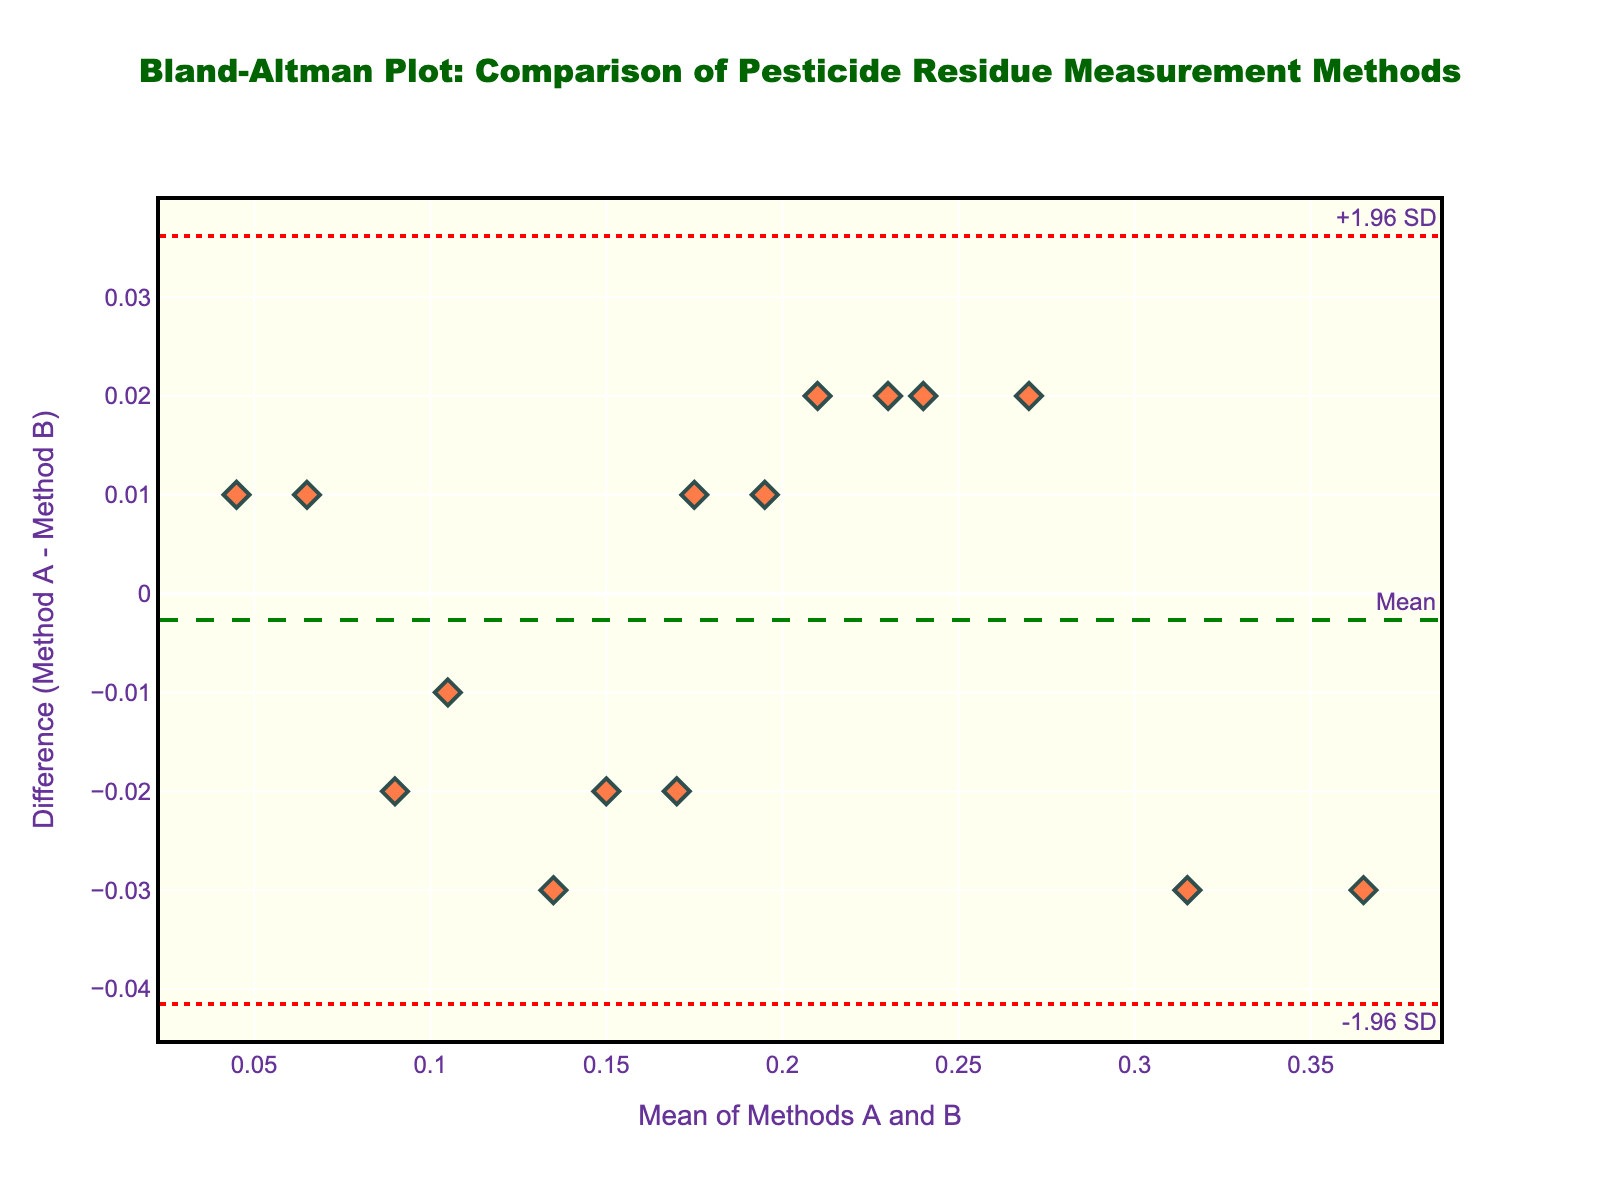What is the title of the figure? The title is usually positioned at the top of the figure. It provides a concise description of what the plot is about. In this case, the title is "Bland-Altman Plot: Comparison of Pesticide Residue Measurement Methods".
Answer: "Bland-Altman Plot: Comparison of Pesticide Residue Measurement Methods" What do the x-axis and y-axis represent in the figure? The x-axis typically represents the mean of the two methods (Method A and Method B) for each data point, and the y-axis shows the difference between Method A and Method B for those data points. The labels on the axes confirm this: "Mean of Methods A and B" for the x-axis and "Difference (Method A - Method B)" for the y-axis.
Answer: The x-axis is the Mean of Methods A and B, and the y-axis is the Difference (Method A - Method B) How many data points are displayed in the plot? To determine the number of data points, count the diamond markers on the scatter plot. Each marker represents a pair of measurements from Method A and Method B. By counting the markers, you can confirm the number of data points. In this case, there are 15 markers.
Answer: 15 What color are the data points in the plot? The color of the data points can be observed visually. In this plot, the markers are colored in a shade of red, described as "rgba(255, 69, 0, 0.7)".
Answer: Red Is there any trend visible in the differences between Methods A and B with respect to the mean of the methods? To identify a trend, look at whether the differences (y-axis values) systematically increase or decrease as the mean (x-axis values) increase. If the points are randomly scattered around the mean difference line with no clear pattern, it suggests no trend. Otherwise, a clear pattern or slope would indicate a trend. In this plot, the points are fairly evenly scattered around the mean difference line without a clear pattern, suggesting no trend.
Answer: No trend visible Which data point has the largest positive difference between Method A and Method B? The largest positive difference will be the data point that is highest above the zero reference line on the y-axis. In this plot, it's the point around x=0.33, y=0.03. By checking the data for verification, this point corresponds to a mean of 0.33 and a difference of 0.03, from the pair (0.30, 0.33).
Answer: The point at (Mean: 0.33, Difference: 0.03) Are there more measurements above or below the mean difference line? To determine this, visually count the number of data points positioned above and below the mean difference line (the dashed green line). Count each group and compare. More data points below the line indicate more frequent lower differences between the methods and vice versa. In this plot, there seem to be 7 points above and 8 points below.
Answer: More measurements below the mean difference line What does it mean if a point is outside the limits of agreement (LoA)? A point outside the LoA (dotted red lines) indicates that the difference between the two methods for that particular measurement pair is unusually large, suggesting potential issues or discrepancies with those measurements. It reflects significant disagreement between the methods for that specific instance. Examine the plot for any points outside these lines. If the plot has no points outside the LoA lines, it means all differences are within acceptable limits of agreement. Given this plot, all points are within the limits.
Answer: It indicates significant disagreement between the methods for that measurement What is the overall agreement between Method A and Method B based on the Bland-Altman plot? The overall agreement can be inferred by the distribution of points relative to the mean difference line and the limits of agreement. If most points are close to the mean difference line and within the LoA, it suggests good agreement. If points are scattered widely and many are outside the LoA, agreement is poor. In this plot, since all points are within the limits of agreement and scatter around the mean difference line with no trends, the agreement between Method A and Method B can be considered good.
Answer: Good agreement 